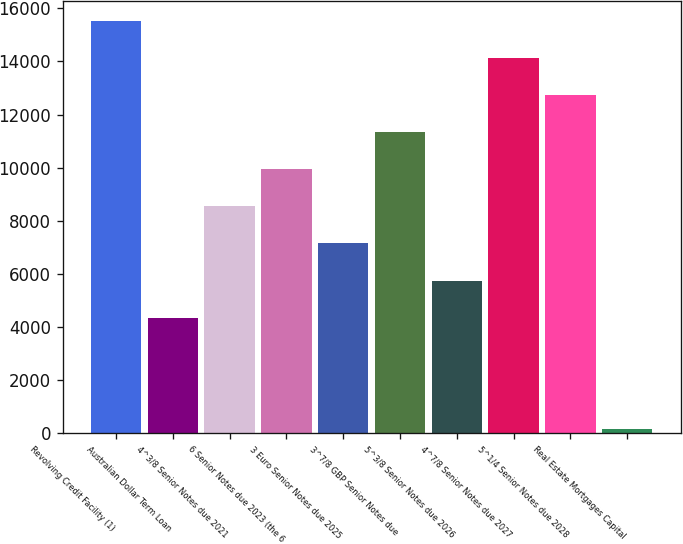Convert chart. <chart><loc_0><loc_0><loc_500><loc_500><bar_chart><fcel>Revolving Credit Facility (1)<fcel>Australian Dollar Term Loan<fcel>4^3/8 Senior Notes due 2021<fcel>6 Senior Notes due 2023 (the 6<fcel>3 Euro Senior Notes due 2025<fcel>3^7/8 GBP Senior Notes due<fcel>5^3/8 Senior Notes due 2026<fcel>4^7/8 Senior Notes due 2027<fcel>5^1/4 Senior Notes due 2028<fcel>Real Estate Mortgages Capital<nl><fcel>15511.6<fcel>4354.8<fcel>8538.6<fcel>9933.2<fcel>7144<fcel>11327.8<fcel>5749.4<fcel>14117<fcel>12722.4<fcel>171<nl></chart> 